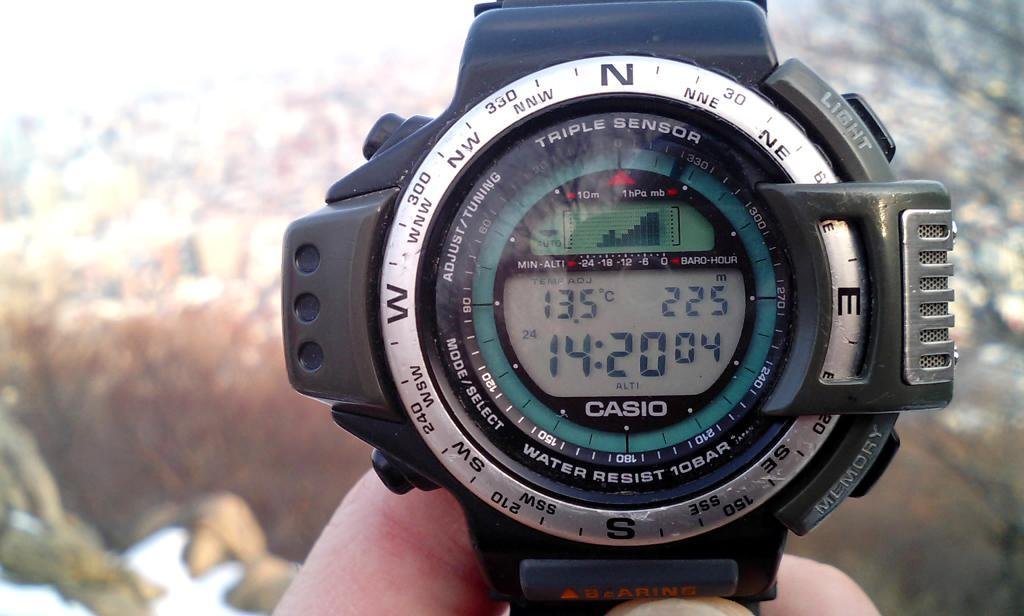Provide a one-sentence caption for the provided image. A person is holding a watch that says Casio. 